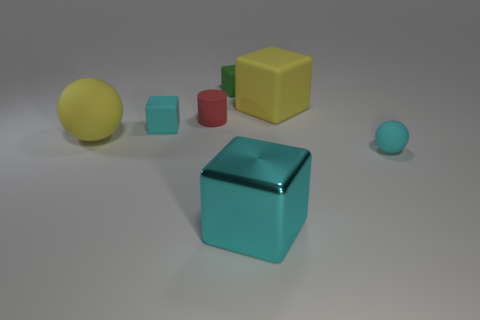What number of small things are green objects or cyan things?
Make the answer very short. 3. There is a big cyan object that is the same shape as the green object; what is its material?
Your answer should be very brief. Metal. Are there any other things that are made of the same material as the large cyan object?
Provide a succinct answer. No. What color is the big sphere?
Provide a succinct answer. Yellow. Does the large shiny thing have the same color as the small rubber sphere?
Give a very brief answer. Yes. What number of tiny green objects are to the left of the yellow rubber object right of the small cylinder?
Your answer should be very brief. 1. What is the size of the cyan object that is both behind the cyan metallic object and to the left of the small cyan sphere?
Your answer should be compact. Small. What material is the small cyan object in front of the large sphere?
Make the answer very short. Rubber. Is there a big matte thing that has the same shape as the large cyan metal object?
Keep it short and to the point. Yes. How many green objects are the same shape as the large cyan thing?
Provide a short and direct response. 1. 